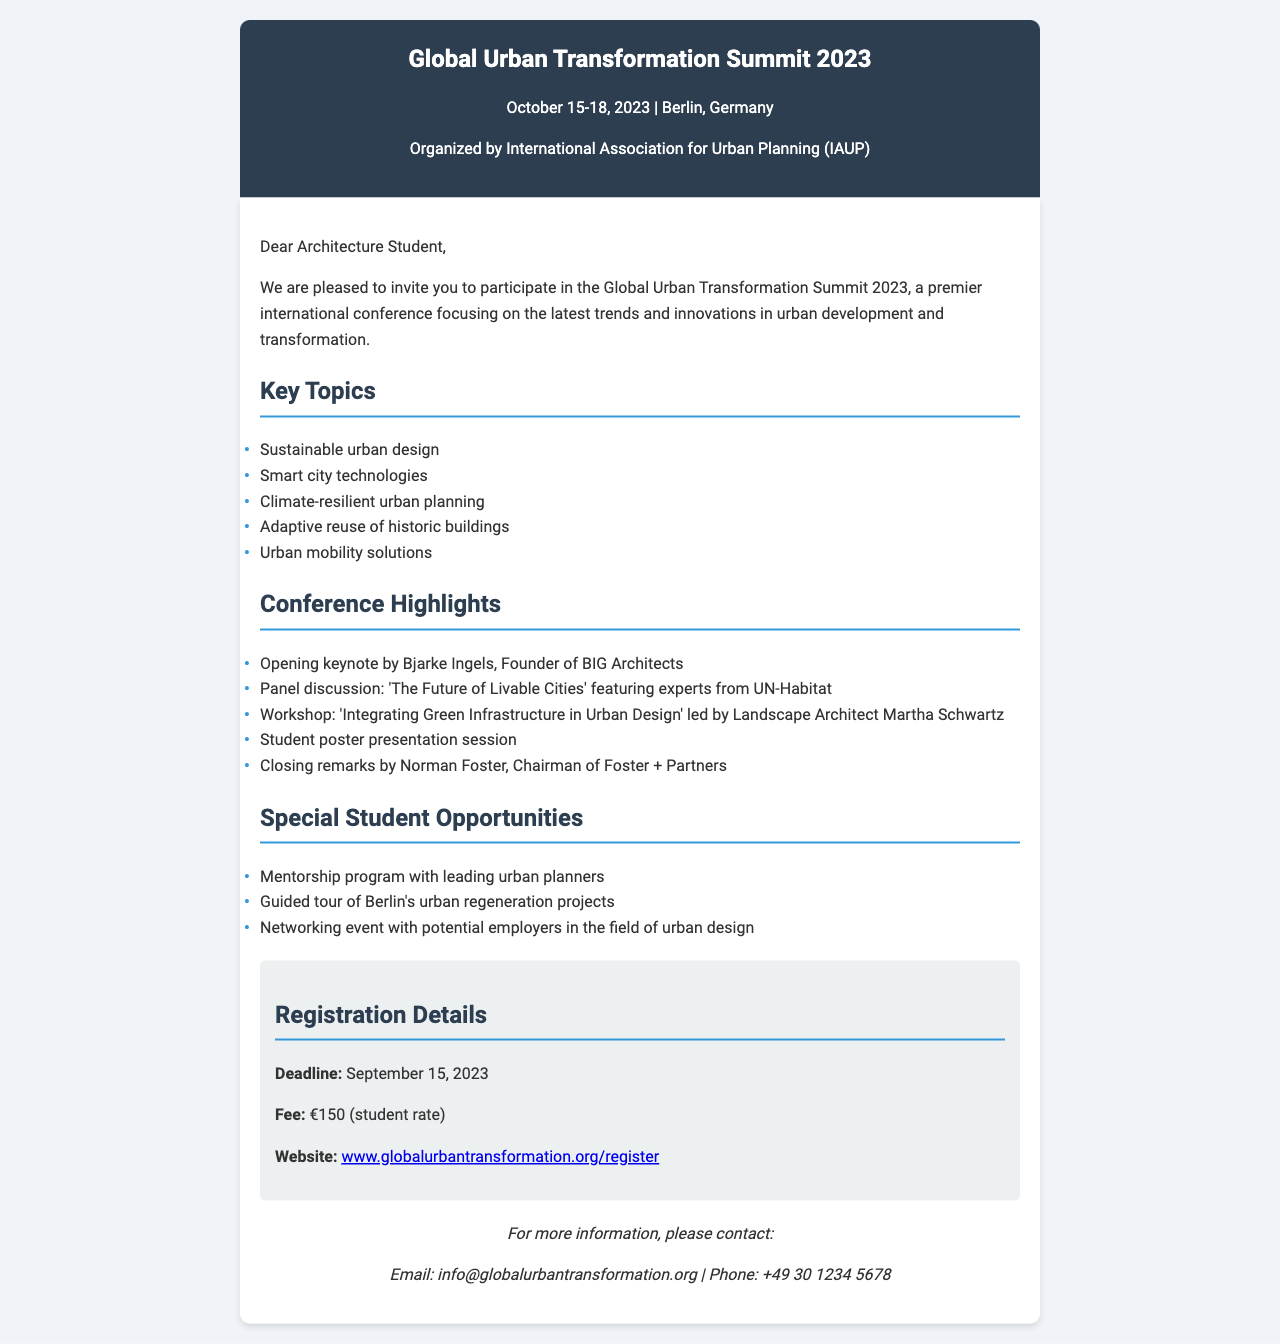What are the dates of the conference? The conference is scheduled to take place from October 15 to October 18, 2023.
Answer: October 15-18, 2023 Who is the organizer of the conference? The conference is organized by the International Association for Urban Planning (IAUP).
Answer: International Association for Urban Planning (IAUP) What is the student registration fee? The document states that the registration fee for students is €150.
Answer: €150 When is the registration deadline? The registration deadline is specified as September 15, 2023.
Answer: September 15, 2023 What is one of the key topics discussed at the conference? The document lists several key topics, one of which is "Sustainable urban design."
Answer: Sustainable urban design What notable keynote speaker will open the conference? The document mentions that the opening keynote speaker is Bjarke Ingels, Founder of BIG Architects.
Answer: Bjarke Ingels Which program offers networking opportunities? The document states there will be a networking event with potential employers in the field of urban design.
Answer: Networking event What is one of the special opportunities for students? The document outlines that there is a mentorship program with leading urban planners.
Answer: Mentorship program 